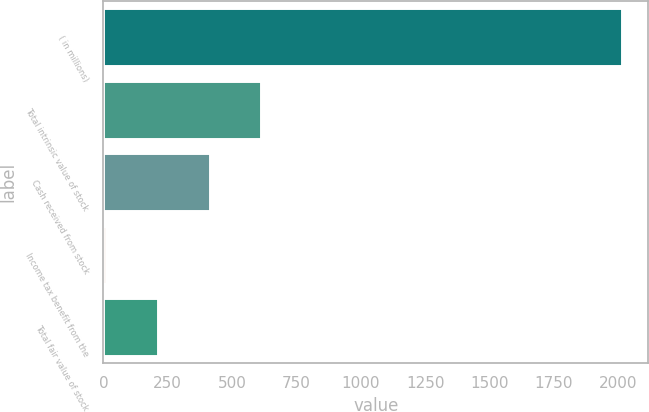Convert chart to OTSL. <chart><loc_0><loc_0><loc_500><loc_500><bar_chart><fcel>( in millions)<fcel>Total intrinsic value of stock<fcel>Cash received from stock<fcel>Income tax benefit from the<fcel>Total fair value of stock<nl><fcel>2016<fcel>613.2<fcel>412.8<fcel>12<fcel>212.4<nl></chart> 